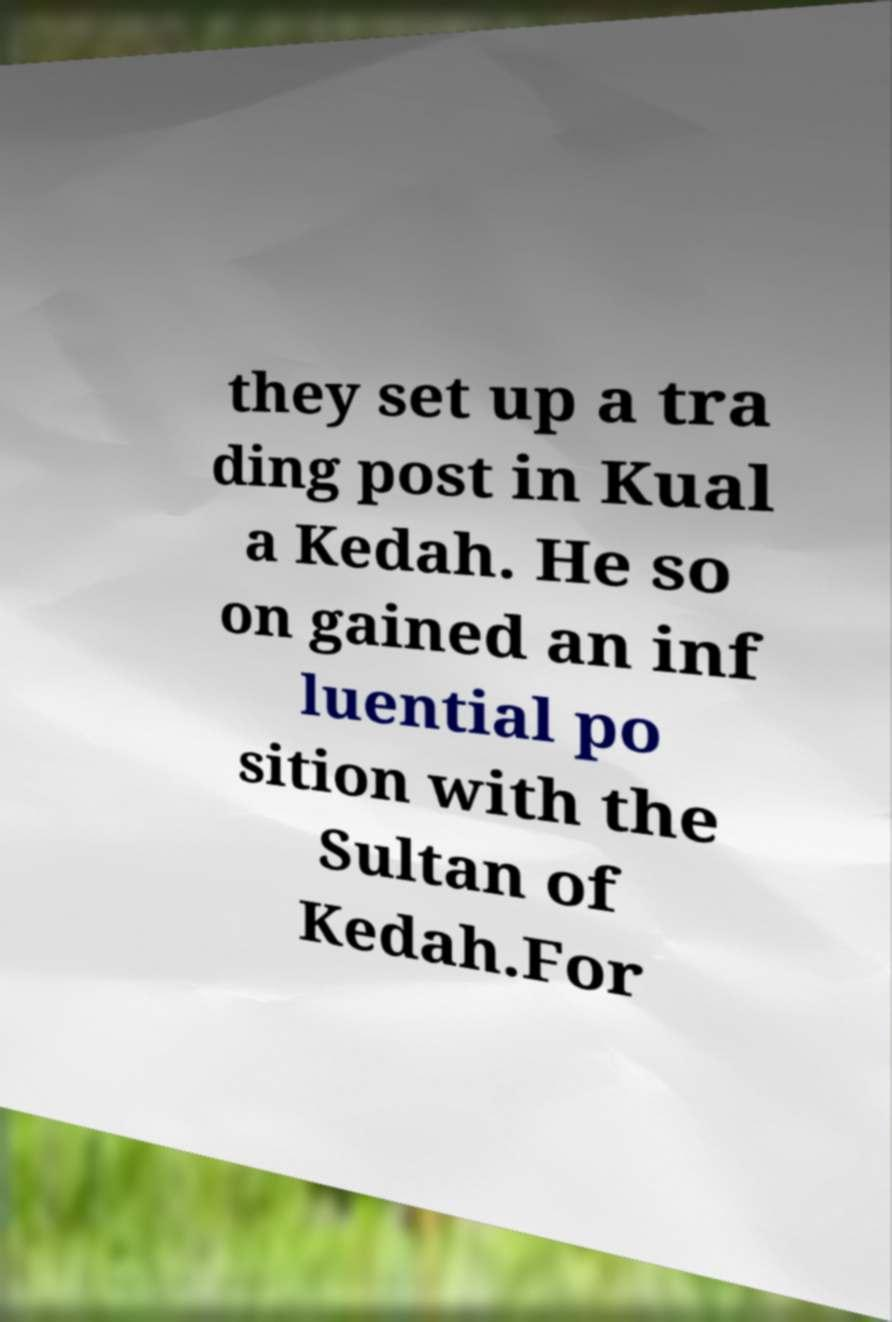Please read and relay the text visible in this image. What does it say? they set up a tra ding post in Kual a Kedah. He so on gained an inf luential po sition with the Sultan of Kedah.For 